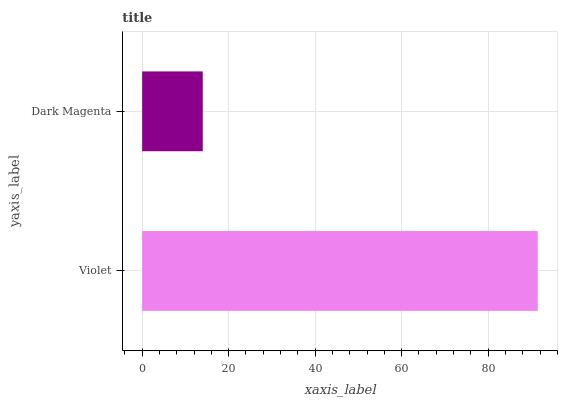Is Dark Magenta the minimum?
Answer yes or no. Yes. Is Violet the maximum?
Answer yes or no. Yes. Is Dark Magenta the maximum?
Answer yes or no. No. Is Violet greater than Dark Magenta?
Answer yes or no. Yes. Is Dark Magenta less than Violet?
Answer yes or no. Yes. Is Dark Magenta greater than Violet?
Answer yes or no. No. Is Violet less than Dark Magenta?
Answer yes or no. No. Is Violet the high median?
Answer yes or no. Yes. Is Dark Magenta the low median?
Answer yes or no. Yes. Is Dark Magenta the high median?
Answer yes or no. No. Is Violet the low median?
Answer yes or no. No. 